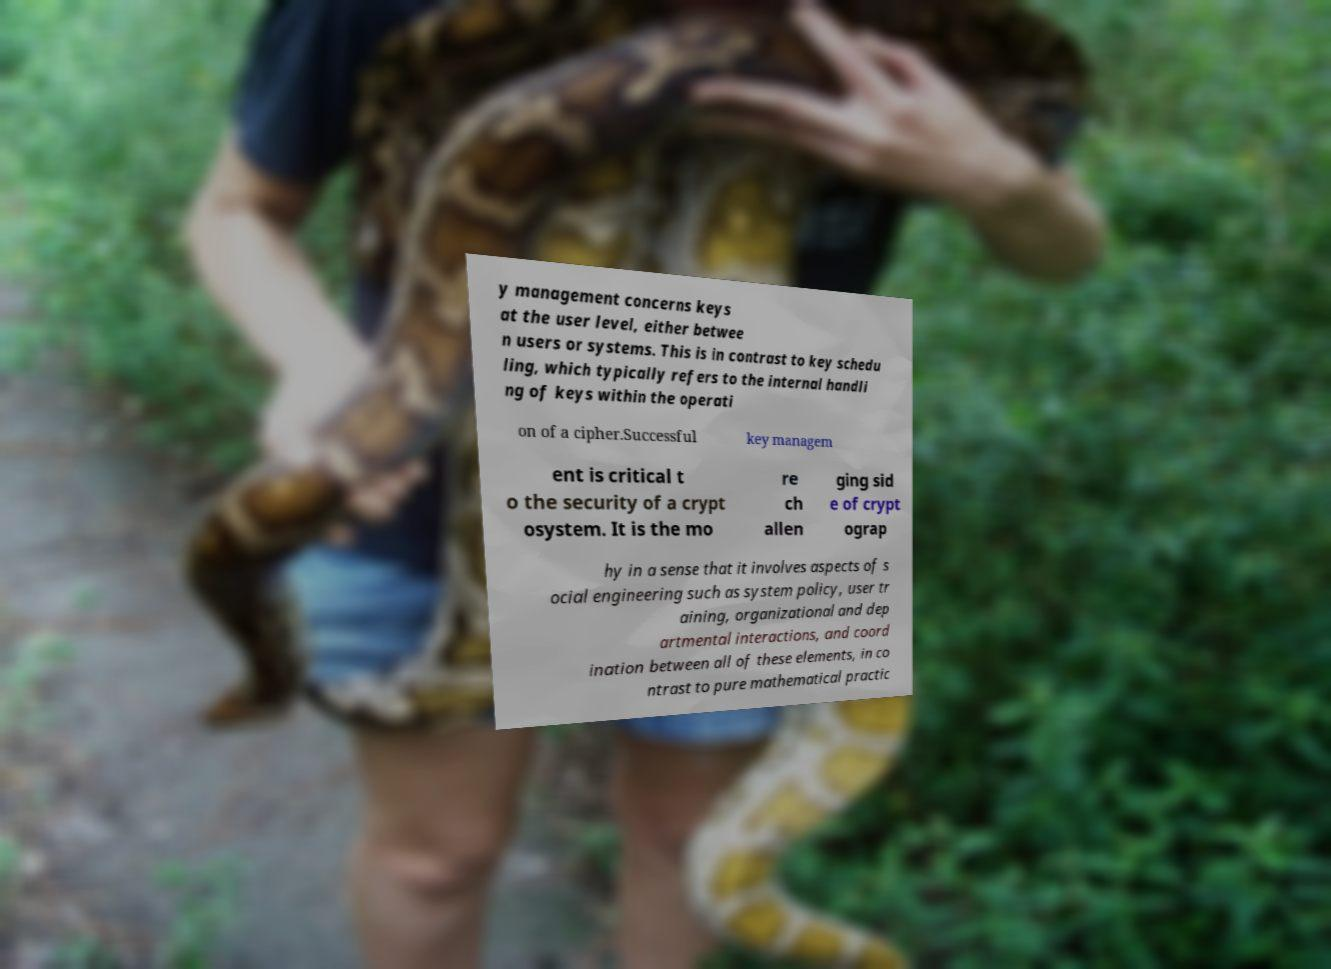What messages or text are displayed in this image? I need them in a readable, typed format. y management concerns keys at the user level, either betwee n users or systems. This is in contrast to key schedu ling, which typically refers to the internal handli ng of keys within the operati on of a cipher.Successful key managem ent is critical t o the security of a crypt osystem. It is the mo re ch allen ging sid e of crypt ograp hy in a sense that it involves aspects of s ocial engineering such as system policy, user tr aining, organizational and dep artmental interactions, and coord ination between all of these elements, in co ntrast to pure mathematical practic 